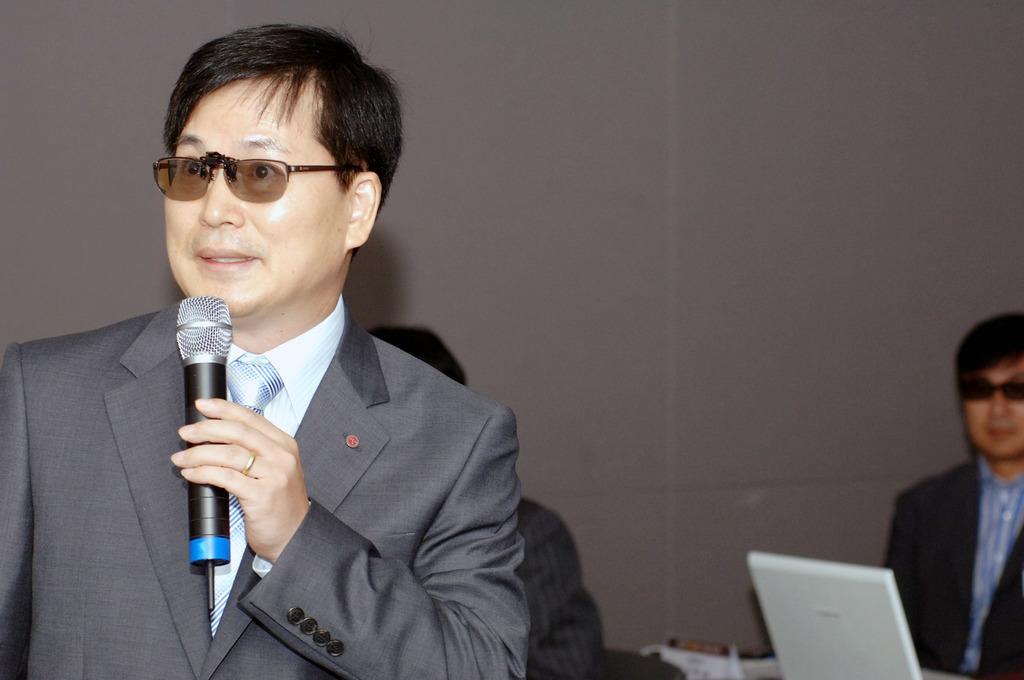Can you describe this image briefly? As we can see in the image there are three people. the man who is standing on the left side is wearing spectacles, brown color jacket and talking on mic and the man on the right side is wearing black color jacket and there is a laptop over here. 